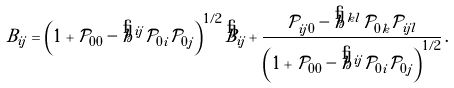<formula> <loc_0><loc_0><loc_500><loc_500>B _ { i j } & = \left ( 1 + \mathcal { P } _ { 0 0 } - \mathring { h } ^ { i j } \mathcal { P } _ { 0 i } \mathcal { P } _ { 0 j } \right ) ^ { 1 / 2 } \mathring { B } _ { i j } + \frac { \mathcal { P } _ { i j 0 } - \mathring { h } ^ { k l } \mathcal { P } _ { 0 k } \mathcal { P } _ { i j l } } { \left ( 1 + \mathcal { P } _ { 0 0 } - \mathring { h } ^ { i j } \mathcal { P } _ { 0 i } \mathcal { P } _ { 0 j } \right ) ^ { 1 / 2 } } \, .</formula> 